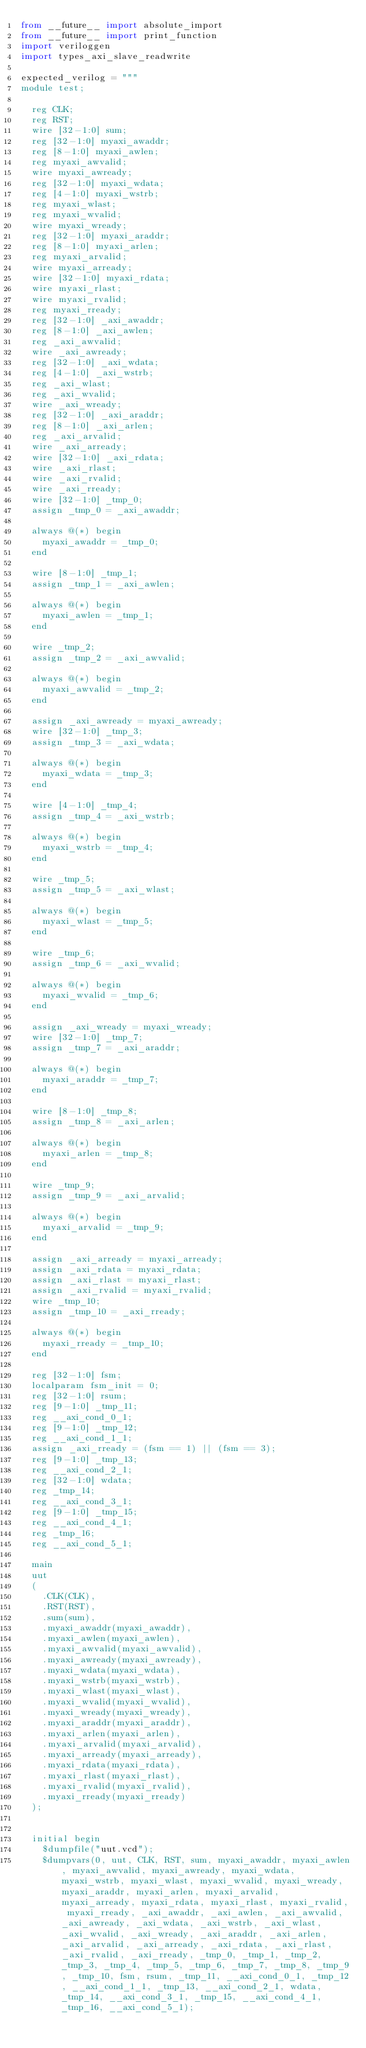Convert code to text. <code><loc_0><loc_0><loc_500><loc_500><_Python_>from __future__ import absolute_import
from __future__ import print_function
import veriloggen
import types_axi_slave_readwrite

expected_verilog = """
module test;

  reg CLK;
  reg RST;
  wire [32-1:0] sum;
  reg [32-1:0] myaxi_awaddr;
  reg [8-1:0] myaxi_awlen;
  reg myaxi_awvalid;
  wire myaxi_awready;
  reg [32-1:0] myaxi_wdata;
  reg [4-1:0] myaxi_wstrb;
  reg myaxi_wlast;
  reg myaxi_wvalid;
  wire myaxi_wready;
  reg [32-1:0] myaxi_araddr;
  reg [8-1:0] myaxi_arlen;
  reg myaxi_arvalid;
  wire myaxi_arready;
  wire [32-1:0] myaxi_rdata;
  wire myaxi_rlast;
  wire myaxi_rvalid;
  reg myaxi_rready;
  reg [32-1:0] _axi_awaddr;
  reg [8-1:0] _axi_awlen;
  reg _axi_awvalid;
  wire _axi_awready;
  reg [32-1:0] _axi_wdata;
  reg [4-1:0] _axi_wstrb;
  reg _axi_wlast;
  reg _axi_wvalid;
  wire _axi_wready;
  reg [32-1:0] _axi_araddr;
  reg [8-1:0] _axi_arlen;
  reg _axi_arvalid;
  wire _axi_arready;
  wire [32-1:0] _axi_rdata;
  wire _axi_rlast;
  wire _axi_rvalid;
  wire _axi_rready;
  wire [32-1:0] _tmp_0;
  assign _tmp_0 = _axi_awaddr;

  always @(*) begin
    myaxi_awaddr = _tmp_0;
  end

  wire [8-1:0] _tmp_1;
  assign _tmp_1 = _axi_awlen;

  always @(*) begin
    myaxi_awlen = _tmp_1;
  end

  wire _tmp_2;
  assign _tmp_2 = _axi_awvalid;

  always @(*) begin
    myaxi_awvalid = _tmp_2;
  end

  assign _axi_awready = myaxi_awready;
  wire [32-1:0] _tmp_3;
  assign _tmp_3 = _axi_wdata;

  always @(*) begin
    myaxi_wdata = _tmp_3;
  end

  wire [4-1:0] _tmp_4;
  assign _tmp_4 = _axi_wstrb;

  always @(*) begin
    myaxi_wstrb = _tmp_4;
  end

  wire _tmp_5;
  assign _tmp_5 = _axi_wlast;

  always @(*) begin
    myaxi_wlast = _tmp_5;
  end

  wire _tmp_6;
  assign _tmp_6 = _axi_wvalid;

  always @(*) begin
    myaxi_wvalid = _tmp_6;
  end

  assign _axi_wready = myaxi_wready;
  wire [32-1:0] _tmp_7;
  assign _tmp_7 = _axi_araddr;

  always @(*) begin
    myaxi_araddr = _tmp_7;
  end

  wire [8-1:0] _tmp_8;
  assign _tmp_8 = _axi_arlen;

  always @(*) begin
    myaxi_arlen = _tmp_8;
  end

  wire _tmp_9;
  assign _tmp_9 = _axi_arvalid;

  always @(*) begin
    myaxi_arvalid = _tmp_9;
  end

  assign _axi_arready = myaxi_arready;
  assign _axi_rdata = myaxi_rdata;
  assign _axi_rlast = myaxi_rlast;
  assign _axi_rvalid = myaxi_rvalid;
  wire _tmp_10;
  assign _tmp_10 = _axi_rready;

  always @(*) begin
    myaxi_rready = _tmp_10;
  end

  reg [32-1:0] fsm;
  localparam fsm_init = 0;
  reg [32-1:0] rsum;
  reg [9-1:0] _tmp_11;
  reg __axi_cond_0_1;
  reg [9-1:0] _tmp_12;
  reg __axi_cond_1_1;
  assign _axi_rready = (fsm == 1) || (fsm == 3);
  reg [9-1:0] _tmp_13;
  reg __axi_cond_2_1;
  reg [32-1:0] wdata;
  reg _tmp_14;
  reg __axi_cond_3_1;
  reg [9-1:0] _tmp_15;
  reg __axi_cond_4_1;
  reg _tmp_16;
  reg __axi_cond_5_1;

  main
  uut
  (
    .CLK(CLK),
    .RST(RST),
    .sum(sum),
    .myaxi_awaddr(myaxi_awaddr),
    .myaxi_awlen(myaxi_awlen),
    .myaxi_awvalid(myaxi_awvalid),
    .myaxi_awready(myaxi_awready),
    .myaxi_wdata(myaxi_wdata),
    .myaxi_wstrb(myaxi_wstrb),
    .myaxi_wlast(myaxi_wlast),
    .myaxi_wvalid(myaxi_wvalid),
    .myaxi_wready(myaxi_wready),
    .myaxi_araddr(myaxi_araddr),
    .myaxi_arlen(myaxi_arlen),
    .myaxi_arvalid(myaxi_arvalid),
    .myaxi_arready(myaxi_arready),
    .myaxi_rdata(myaxi_rdata),
    .myaxi_rlast(myaxi_rlast),
    .myaxi_rvalid(myaxi_rvalid),
    .myaxi_rready(myaxi_rready)
  );


  initial begin
    $dumpfile("uut.vcd");
    $dumpvars(0, uut, CLK, RST, sum, myaxi_awaddr, myaxi_awlen, myaxi_awvalid, myaxi_awready, myaxi_wdata, myaxi_wstrb, myaxi_wlast, myaxi_wvalid, myaxi_wready, myaxi_araddr, myaxi_arlen, myaxi_arvalid, myaxi_arready, myaxi_rdata, myaxi_rlast, myaxi_rvalid, myaxi_rready, _axi_awaddr, _axi_awlen, _axi_awvalid, _axi_awready, _axi_wdata, _axi_wstrb, _axi_wlast, _axi_wvalid, _axi_wready, _axi_araddr, _axi_arlen, _axi_arvalid, _axi_arready, _axi_rdata, _axi_rlast, _axi_rvalid, _axi_rready, _tmp_0, _tmp_1, _tmp_2, _tmp_3, _tmp_4, _tmp_5, _tmp_6, _tmp_7, _tmp_8, _tmp_9, _tmp_10, fsm, rsum, _tmp_11, __axi_cond_0_1, _tmp_12, __axi_cond_1_1, _tmp_13, __axi_cond_2_1, wdata, _tmp_14, __axi_cond_3_1, _tmp_15, __axi_cond_4_1, _tmp_16, __axi_cond_5_1);</code> 